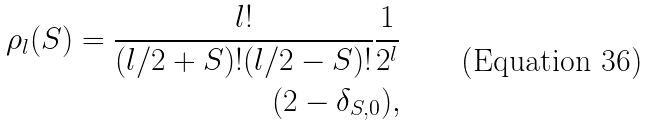<formula> <loc_0><loc_0><loc_500><loc_500>\rho _ { l } ( S ) = \frac { l ! } { ( l / 2 + S ) ! ( l / 2 - S ) ! } \frac { 1 } { 2 ^ { l } } \\ ( 2 - \delta _ { S , 0 } ) ,</formula> 